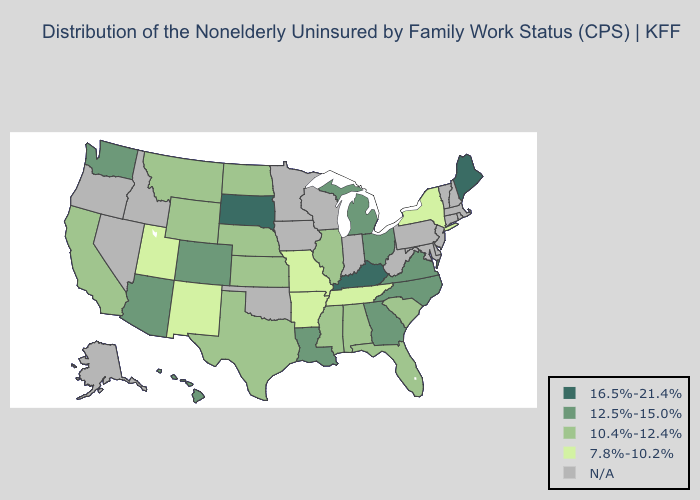Among the states that border Texas , does Louisiana have the lowest value?
Quick response, please. No. What is the value of Alabama?
Write a very short answer. 10.4%-12.4%. What is the lowest value in states that border Florida?
Give a very brief answer. 10.4%-12.4%. Among the states that border Indiana , does Michigan have the lowest value?
Concise answer only. No. Name the states that have a value in the range N/A?
Concise answer only. Alaska, Connecticut, Delaware, Idaho, Indiana, Iowa, Maryland, Massachusetts, Minnesota, Nevada, New Hampshire, New Jersey, Oklahoma, Oregon, Pennsylvania, Rhode Island, Vermont, West Virginia, Wisconsin. Does the first symbol in the legend represent the smallest category?
Write a very short answer. No. What is the value of Wisconsin?
Concise answer only. N/A. Name the states that have a value in the range 7.8%-10.2%?
Quick response, please. Arkansas, Missouri, New Mexico, New York, Tennessee, Utah. Name the states that have a value in the range N/A?
Concise answer only. Alaska, Connecticut, Delaware, Idaho, Indiana, Iowa, Maryland, Massachusetts, Minnesota, Nevada, New Hampshire, New Jersey, Oklahoma, Oregon, Pennsylvania, Rhode Island, Vermont, West Virginia, Wisconsin. What is the value of Oregon?
Keep it brief. N/A. Which states have the lowest value in the South?
Quick response, please. Arkansas, Tennessee. Among the states that border Iowa , does South Dakota have the highest value?
Write a very short answer. Yes. Name the states that have a value in the range 10.4%-12.4%?
Write a very short answer. Alabama, California, Florida, Illinois, Kansas, Mississippi, Montana, Nebraska, North Dakota, South Carolina, Texas, Wyoming. Which states have the lowest value in the USA?
Short answer required. Arkansas, Missouri, New Mexico, New York, Tennessee, Utah. 